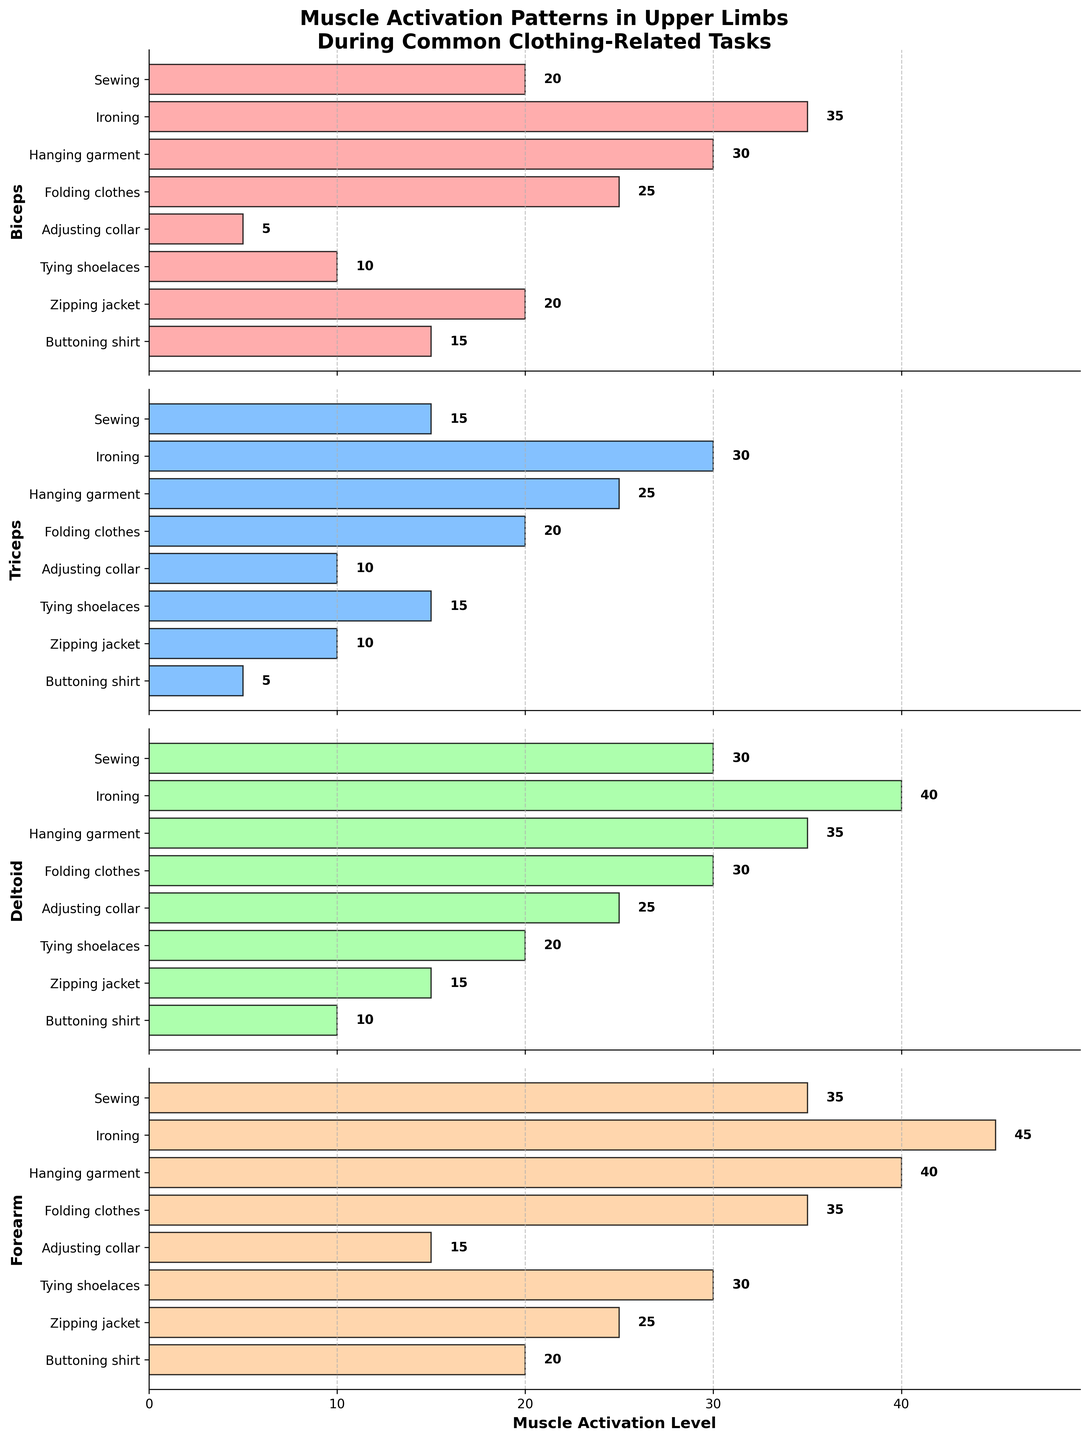What is the title of the figure? The title of the figure is displayed at the top and is typically in a larger and bolder font.
Answer: Muscle Activation Patterns in Upper Limbs During Common Clothing-Related Tasks How many different tasks are analyzed in the figure? Each muscle subplot has horizontal bars representing different tasks. Counting these bars will give the total number of tasks.
Answer: 8 Which muscle shows the highest activation level for the "Hanging garment" task? In the subplot labeled "Hanging garment", we look for the tallest horizontal bar.
Answer: Forearm Compare the activation levels of Biceps and Triceps during the "Ironing" task. Which one is higher and by how much? Find the horizontal bars for the Biceps and Triceps in the subplot for "Ironing" and compare their lengths. The difference is the height of the longer minus the height of the shorter.
Answer: Biceps is higher by 5 units Which muscle has the lowest activation level during "Adjusting collar"? In the "Adjusting collar" subplot, identify the shortest horizontal bar.
Answer: Biceps What is the average activation level of the Forearm muscle across all tasks? Find the values for the Forearm muscle across all tasks and compute the average. (20+25+30+15+35+40+45+35)/8.
Answer: 30.625 For the "Buttoning shirt" task, rank the muscles from most to least activated. Find the activation levels for each muscle during "Buttoning shirt," then sort them from highest to lowest.
Answer: Forearm, Biceps, Deltoid, Triceps Which muscles have an activation level greater than 30 during the "Folding clothes" task? Identify the muscles with bars longer than 30 units during "Folding clothes".
Answer: Deltoid, Forearm Determine the median activation level of the Deltoid muscle across all tasks. List the activation levels of the Deltoid muscle, sort them, and find the middle value (or the average of the two middle values).
Answer: 27.5 (sorted values: 10, 15, 20, 25, 30, 30, 35, 40) Which task has the highest collective muscle activation when summing all four muscles? For each task, sum the activation levels of all four muscles and find the task with the highest sum.
Answer: Ironing (sum = 150) 